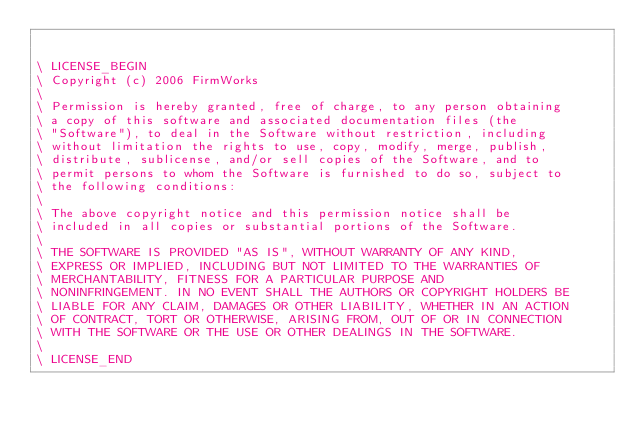Convert code to text. <code><loc_0><loc_0><loc_500><loc_500><_Forth_>

\ LICENSE_BEGIN
\ Copyright (c) 2006 FirmWorks
\ 
\ Permission is hereby granted, free of charge, to any person obtaining
\ a copy of this software and associated documentation files (the
\ "Software"), to deal in the Software without restriction, including
\ without limitation the rights to use, copy, modify, merge, publish,
\ distribute, sublicense, and/or sell copies of the Software, and to
\ permit persons to whom the Software is furnished to do so, subject to
\ the following conditions:
\ 
\ The above copyright notice and this permission notice shall be
\ included in all copies or substantial portions of the Software.
\ 
\ THE SOFTWARE IS PROVIDED "AS IS", WITHOUT WARRANTY OF ANY KIND,
\ EXPRESS OR IMPLIED, INCLUDING BUT NOT LIMITED TO THE WARRANTIES OF
\ MERCHANTABILITY, FITNESS FOR A PARTICULAR PURPOSE AND
\ NONINFRINGEMENT. IN NO EVENT SHALL THE AUTHORS OR COPYRIGHT HOLDERS BE
\ LIABLE FOR ANY CLAIM, DAMAGES OR OTHER LIABILITY, WHETHER IN AN ACTION
\ OF CONTRACT, TORT OR OTHERWISE, ARISING FROM, OUT OF OR IN CONNECTION
\ WITH THE SOFTWARE OR THE USE OR OTHER DEALINGS IN THE SOFTWARE.
\
\ LICENSE_END
</code> 